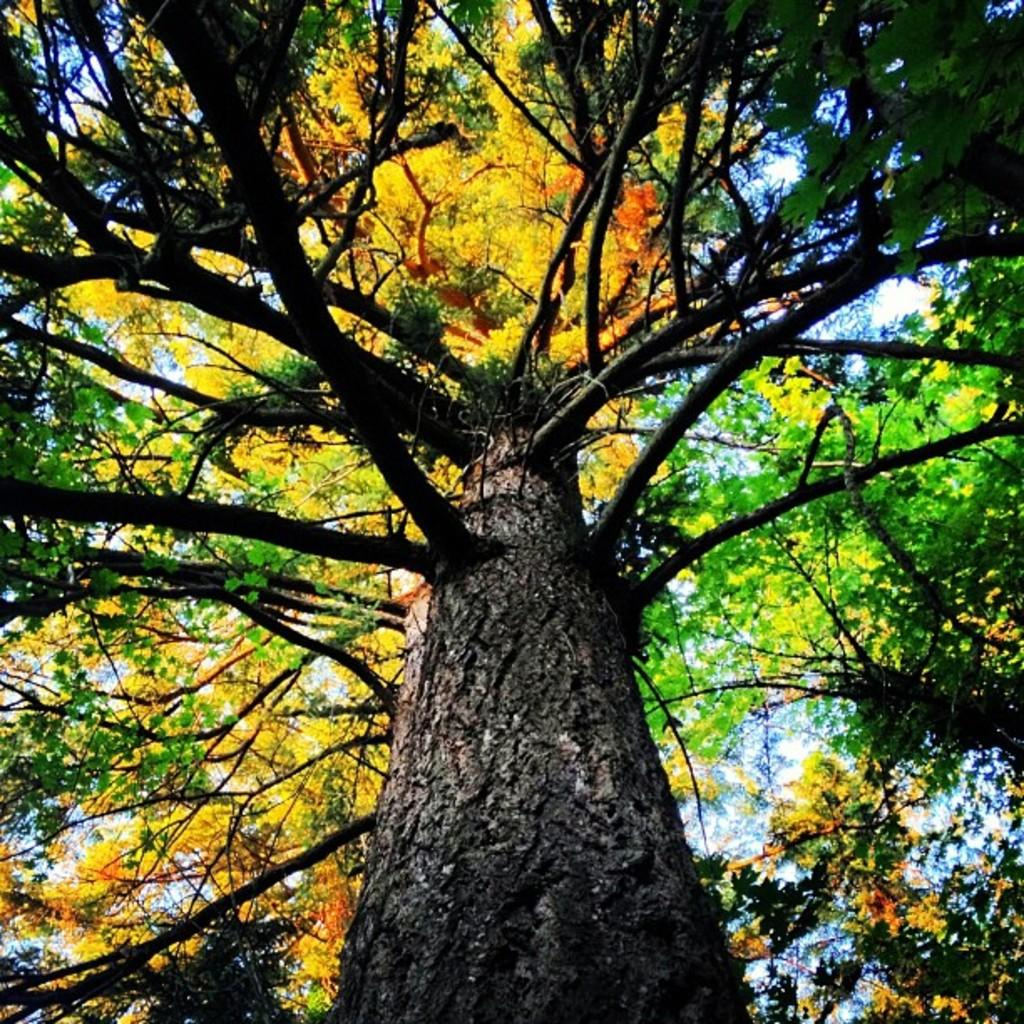What is the main subject in the center of the image? There is a tree in the center of the image. What can be seen in the background of the image? The sky is visible in the background of the image. How many sisters are sitting on the branches of the tree in the image? There are no sisters present in the image; it only features a tree and the sky. 